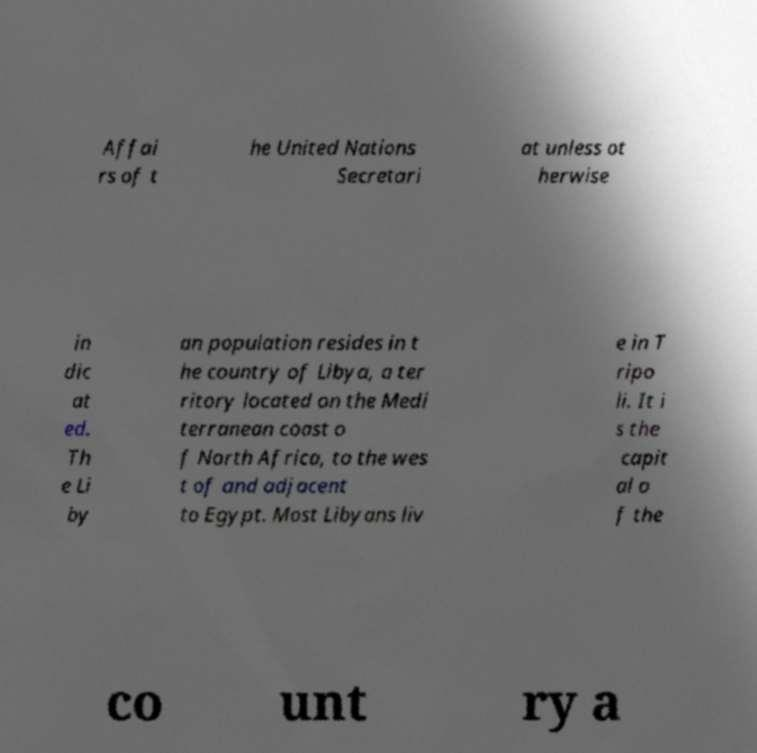Can you accurately transcribe the text from the provided image for me? Affai rs of t he United Nations Secretari at unless ot herwise in dic at ed. Th e Li by an population resides in t he country of Libya, a ter ritory located on the Medi terranean coast o f North Africa, to the wes t of and adjacent to Egypt. Most Libyans liv e in T ripo li. It i s the capit al o f the co unt ry a 